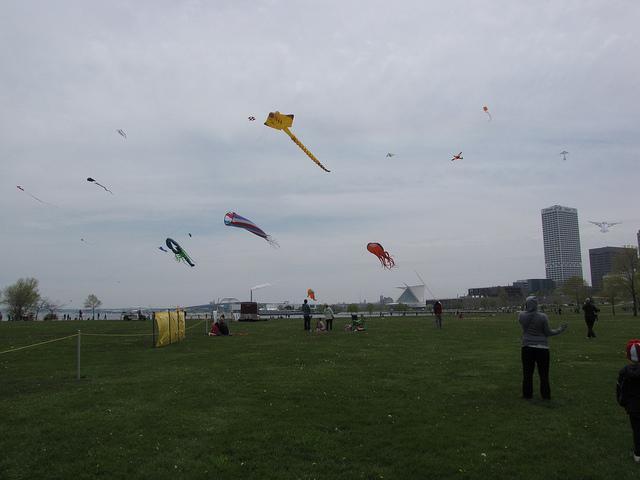How many people can be seen?
Give a very brief answer. 2. How many motorcycles have an american flag on them?
Give a very brief answer. 0. 